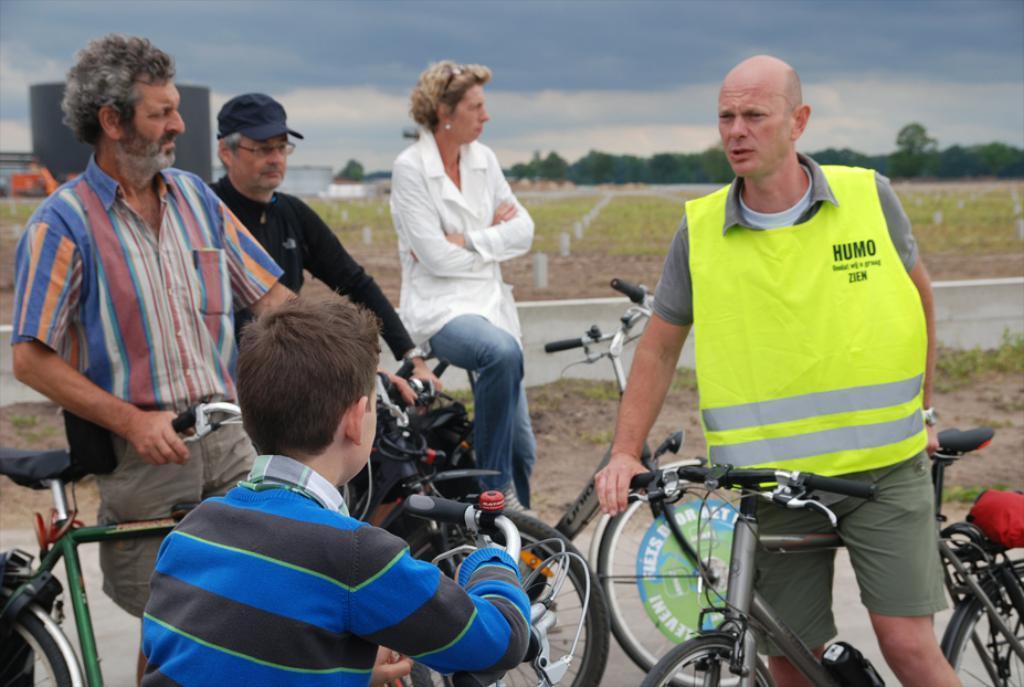Please provide a concise description of this image. Here there are group of people standing with bicycles in their hand and the sky is cloudy 